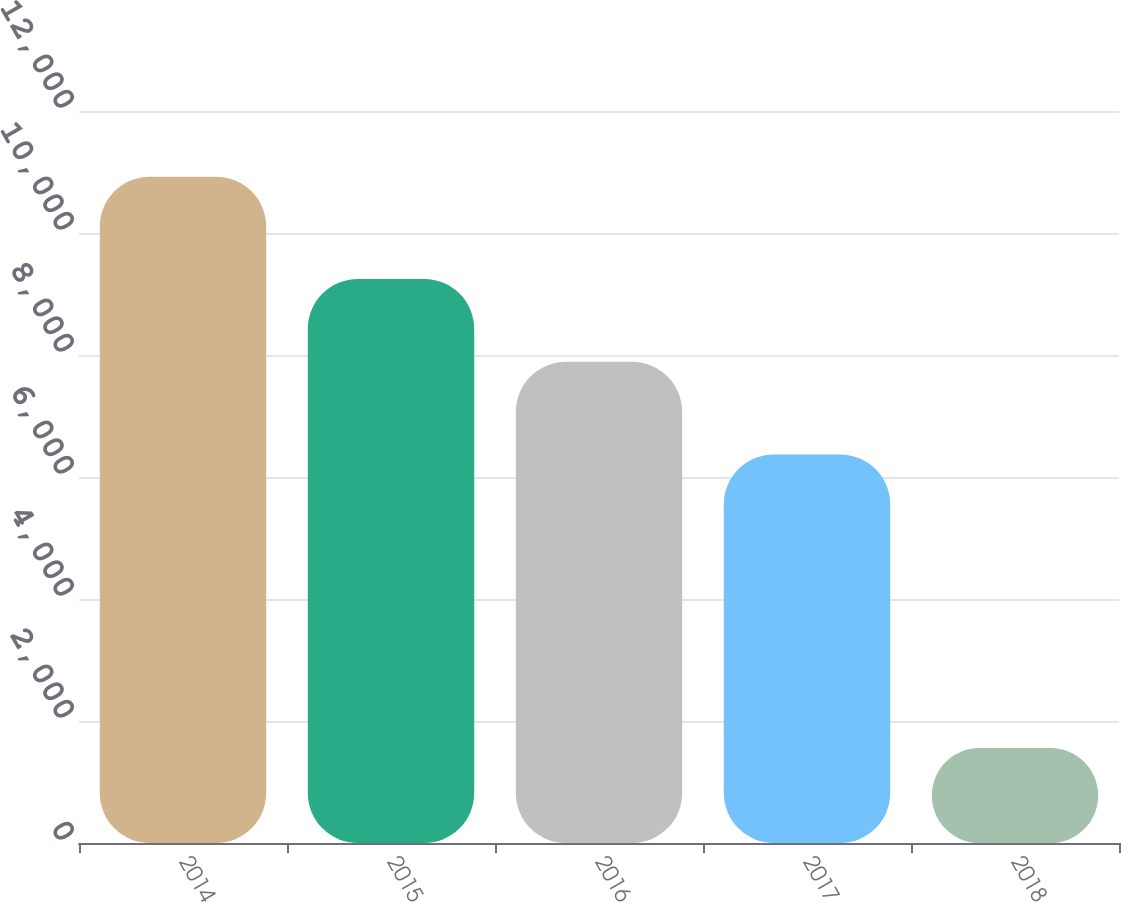Convert chart to OTSL. <chart><loc_0><loc_0><loc_500><loc_500><bar_chart><fcel>2014<fcel>2015<fcel>2016<fcel>2017<fcel>2018<nl><fcel>10924<fcel>9247<fcel>7888<fcel>6370<fcel>1556<nl></chart> 